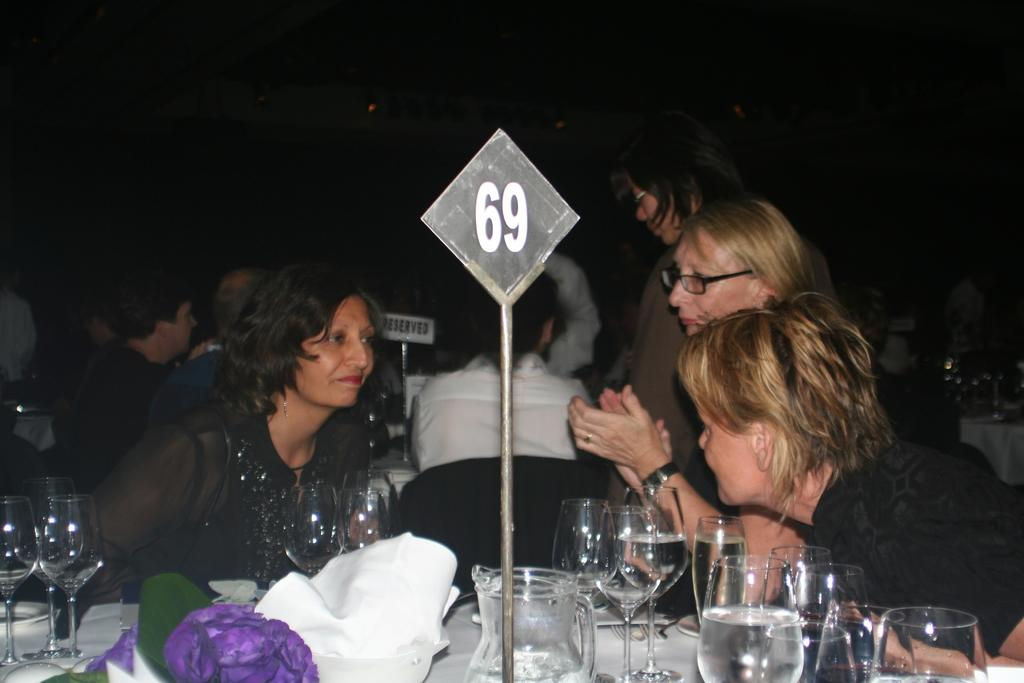Who is present at the table in the image? There are women and men sitting at the table in the image. What objects can be seen on the table? There are glasses on the table. What type of potato is being served at the table in the image? There is no potato present in the image; only glasses and people sitting at the table are visible. 